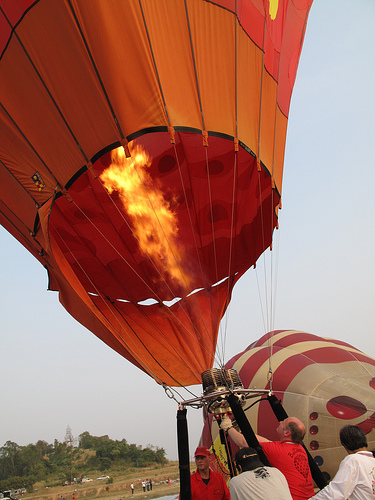<image>
Is the balloon under the flame? No. The balloon is not positioned under the flame. The vertical relationship between these objects is different. Is the balloon behind the person? Yes. From this viewpoint, the balloon is positioned behind the person, with the person partially or fully occluding the balloon. Where is the fire in relation to the balloon? Is it in the balloon? Yes. The fire is contained within or inside the balloon, showing a containment relationship. 